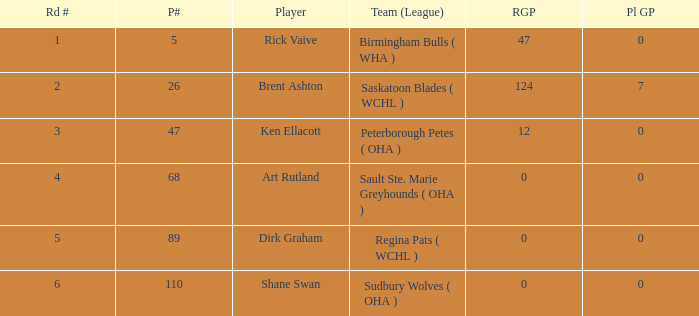Can you give me this table as a dict? {'header': ['Rd #', 'P#', 'Player', 'Team (League)', 'RGP', 'Pl GP'], 'rows': [['1', '5', 'Rick Vaive', 'Birmingham Bulls ( WHA )', '47', '0'], ['2', '26', 'Brent Ashton', 'Saskatoon Blades ( WCHL )', '124', '7'], ['3', '47', 'Ken Ellacott', 'Peterborough Petes ( OHA )', '12', '0'], ['4', '68', 'Art Rutland', 'Sault Ste. Marie Greyhounds ( OHA )', '0', '0'], ['5', '89', 'Dirk Graham', 'Regina Pats ( WCHL )', '0', '0'], ['6', '110', 'Shane Swan', 'Sudbury Wolves ( OHA )', '0', '0']]} How many rounds exist for picks under 5? 0.0. 